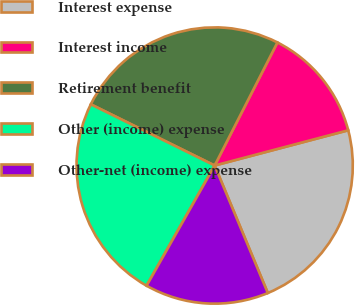Convert chart to OTSL. <chart><loc_0><loc_0><loc_500><loc_500><pie_chart><fcel>Interest expense<fcel>Interest income<fcel>Retirement benefit<fcel>Other (income) expense<fcel>Other-net (income) expense<nl><fcel>22.82%<fcel>13.39%<fcel>25.2%<fcel>24.1%<fcel>14.49%<nl></chart> 